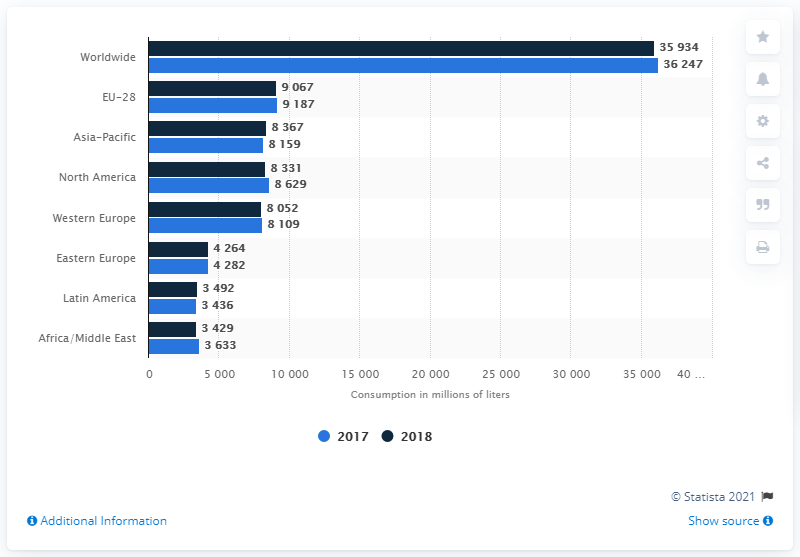Draw attention to some important aspects in this diagram. The amount of fruit juice and nectar consumed in the EU-28 countries in 2018 was 9,187... 